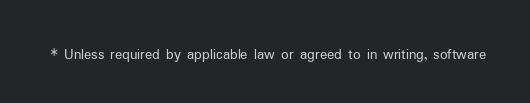Convert code to text. <code><loc_0><loc_0><loc_500><loc_500><_Java_> * Unless required by applicable law or agreed to in writing, software</code> 